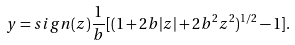<formula> <loc_0><loc_0><loc_500><loc_500>y = s i g n ( z ) \frac { 1 } { b } [ ( 1 + 2 b | z | + 2 b ^ { 2 } z ^ { 2 } ) ^ { 1 / 2 } - 1 ] .</formula> 